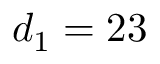<formula> <loc_0><loc_0><loc_500><loc_500>d _ { 1 } = 2 3</formula> 